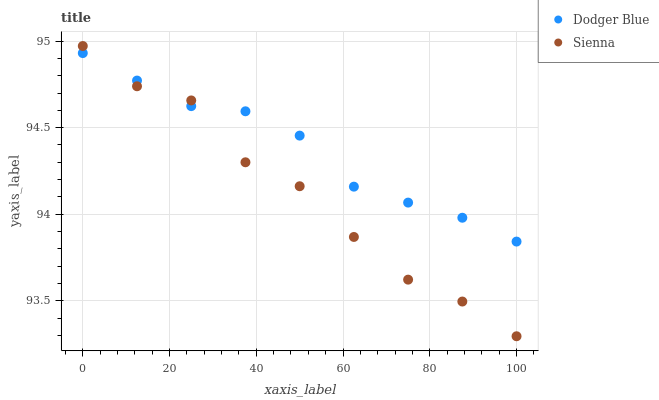Does Sienna have the minimum area under the curve?
Answer yes or no. Yes. Does Dodger Blue have the maximum area under the curve?
Answer yes or no. Yes. Does Dodger Blue have the minimum area under the curve?
Answer yes or no. No. Is Dodger Blue the smoothest?
Answer yes or no. Yes. Is Sienna the roughest?
Answer yes or no. Yes. Is Dodger Blue the roughest?
Answer yes or no. No. Does Sienna have the lowest value?
Answer yes or no. Yes. Does Dodger Blue have the lowest value?
Answer yes or no. No. Does Sienna have the highest value?
Answer yes or no. Yes. Does Dodger Blue have the highest value?
Answer yes or no. No. Does Dodger Blue intersect Sienna?
Answer yes or no. Yes. Is Dodger Blue less than Sienna?
Answer yes or no. No. Is Dodger Blue greater than Sienna?
Answer yes or no. No. 